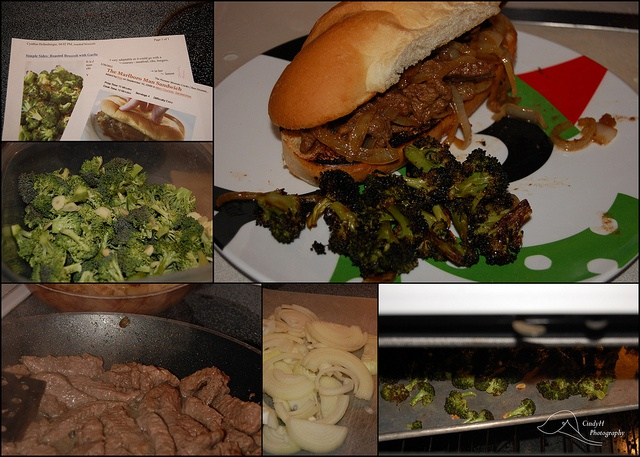Describe the objects in this image and their specific colors. I can see sandwich in black, maroon, brown, and tan tones, broccoli in black, maroon, olive, and darkgray tones, broccoli in black, olive, and darkgreen tones, book in black, darkgray, and maroon tones, and bowl in black, maroon, and brown tones in this image. 